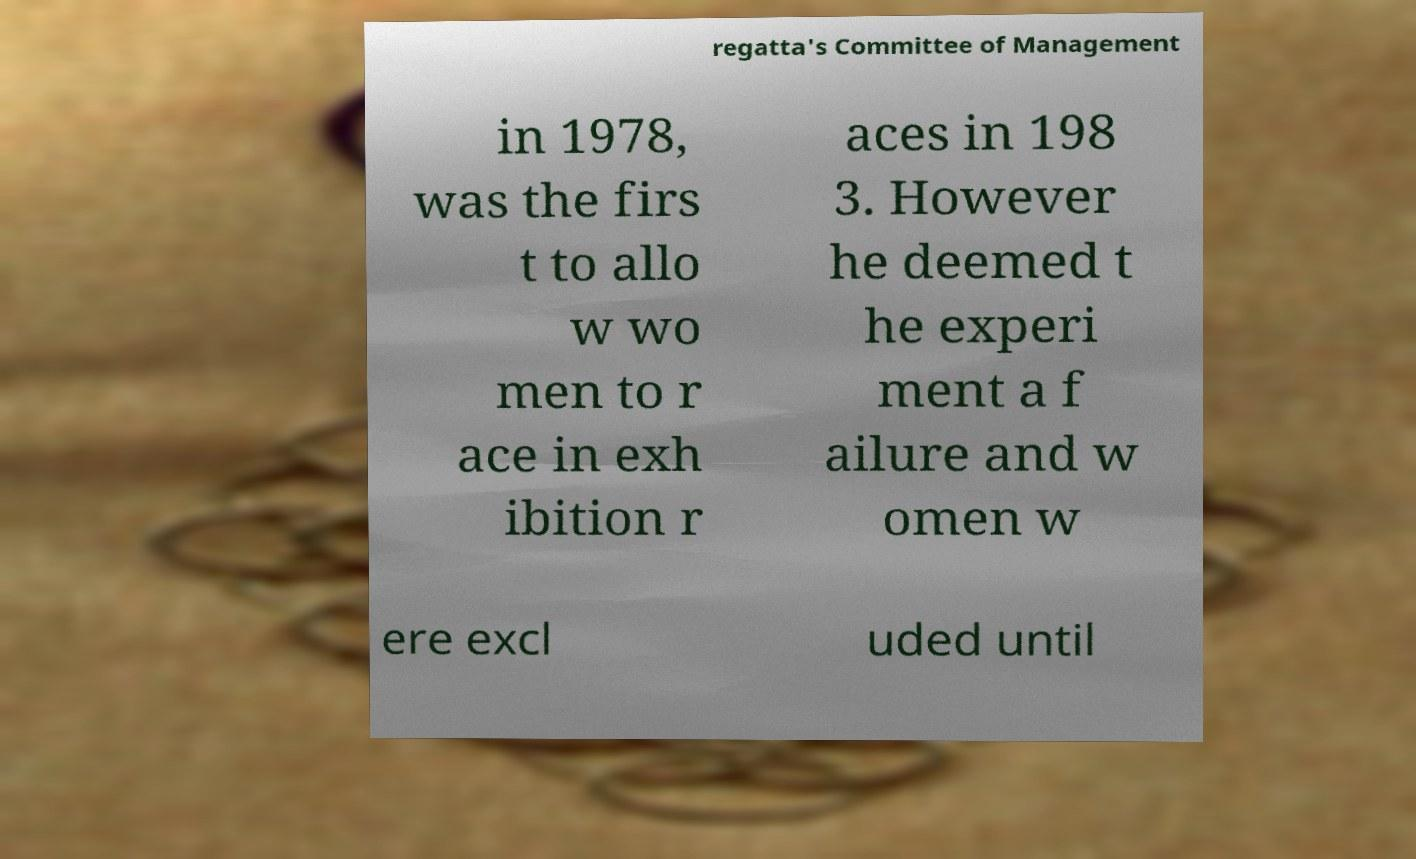Please read and relay the text visible in this image. What does it say? regatta's Committee of Management in 1978, was the firs t to allo w wo men to r ace in exh ibition r aces in 198 3. However he deemed t he experi ment a f ailure and w omen w ere excl uded until 